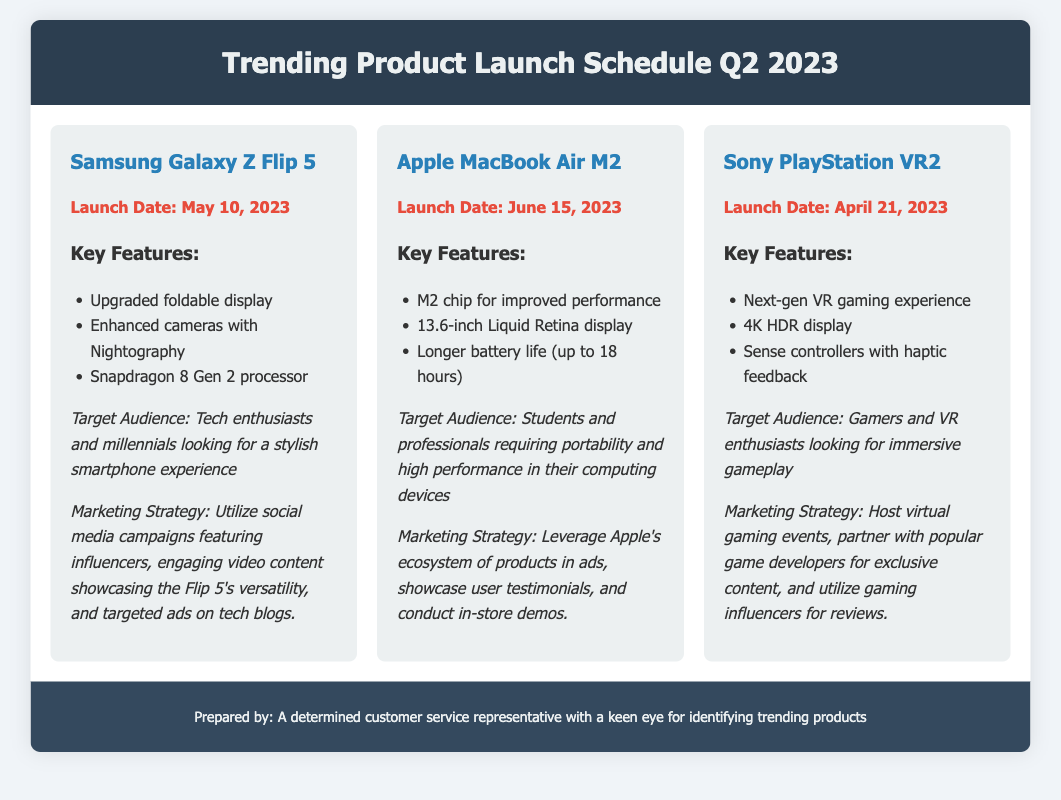What is the launch date for the Samsung Galaxy Z Flip 5? The launch date for the Samsung Galaxy Z Flip 5 is stated as May 10, 2023.
Answer: May 10, 2023 What are the key features of the Apple MacBook Air M2? The key features include the M2 chip for improved performance, a 13.6-inch Liquid Retina display, and longer battery life (up to 18 hours).
Answer: M2 chip, 13.6-inch Liquid Retina display, longer battery life (up to 18 hours) Who is the target audience for the Sony PlayStation VR2? The target audience for the Sony PlayStation VR2 includes gamers and VR enthusiasts looking for immersive gameplay.
Answer: Gamers and VR enthusiasts What marketing strategy is used for the Samsung Galaxy Z Flip 5? The marketing strategy includes social media campaigns featuring influencers, engaging video content showcasing versatility, and targeted ads on tech blogs.
Answer: Social media campaigns, influencer marketing, targeted ads When is the launch date for the Apple MacBook Air M2? The launch date for the Apple MacBook Air M2 is June 15, 2023.
Answer: June 15, 2023 What key feature is highlighted for the Sony PlayStation VR2? The highlighted key feature for the Sony PlayStation VR2 is the next-gen VR gaming experience.
Answer: Next-gen VR gaming experience What product is targeting students and professionals? The product targeting students and professionals is the Apple MacBook Air M2, designed for portability and high performance.
Answer: Apple MacBook Air M2 What is the marketing strategy for the Sony PlayStation VR2? The marketing strategy includes hosting virtual gaming events, partnering with game developers for exclusive content, and utilizing gaming influencers for reviews.
Answer: Virtual gaming events, partnerships, gaming influencers 